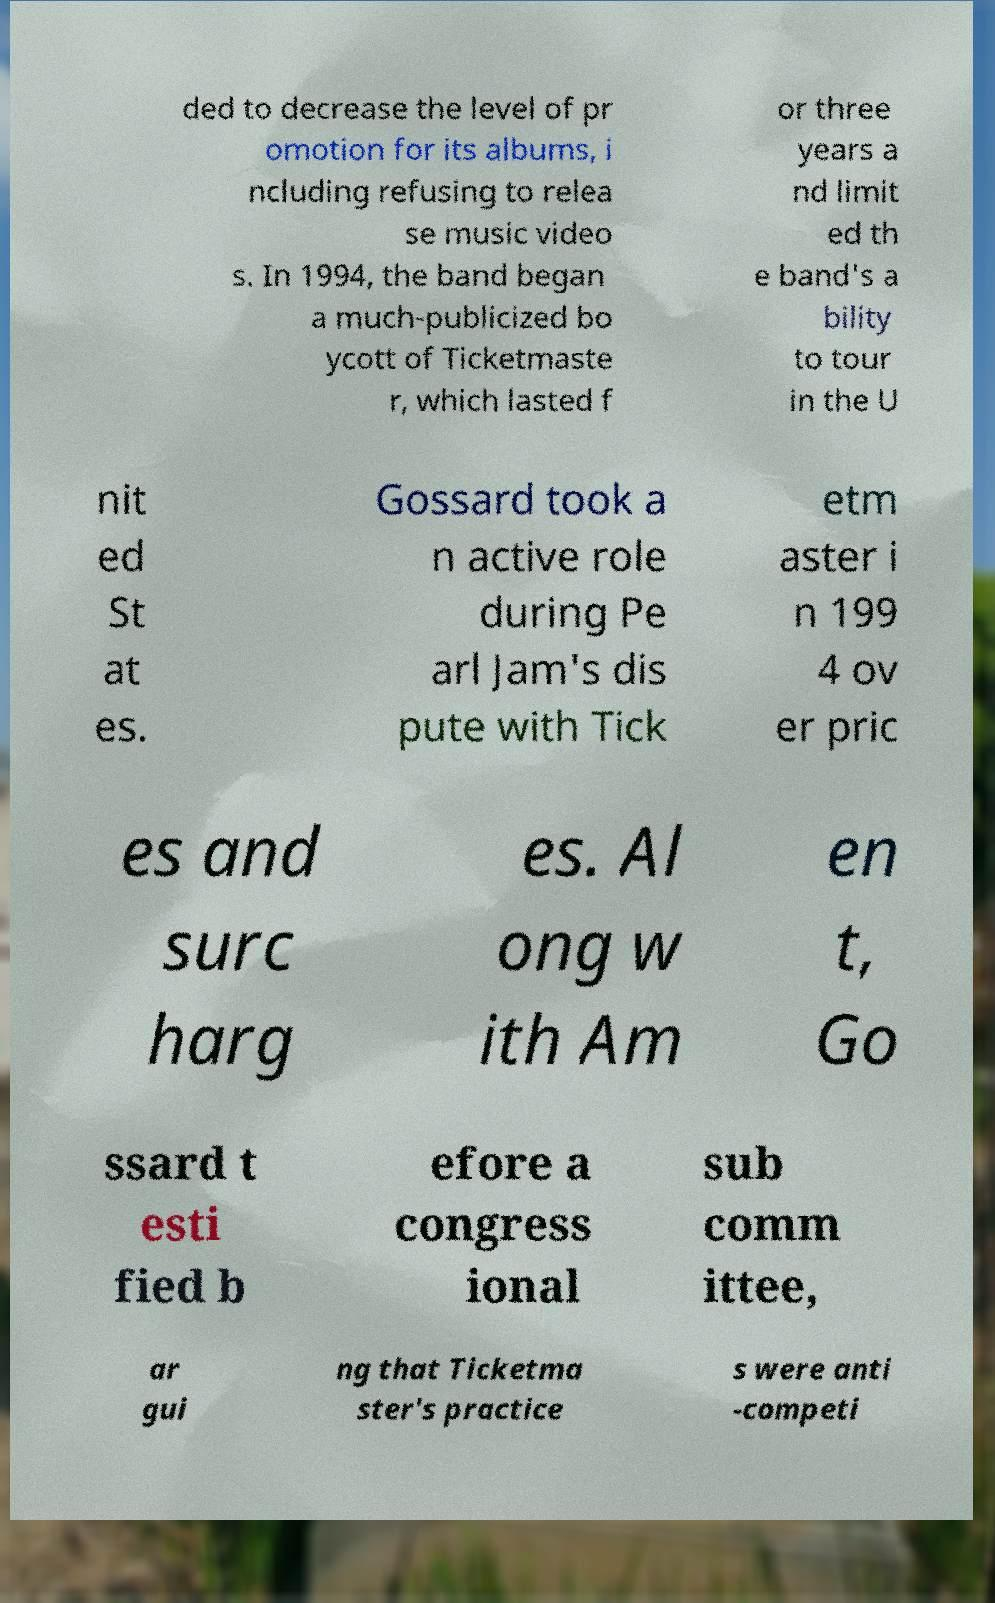I need the written content from this picture converted into text. Can you do that? ded to decrease the level of pr omotion for its albums, i ncluding refusing to relea se music video s. In 1994, the band began a much-publicized bo ycott of Ticketmaste r, which lasted f or three years a nd limit ed th e band's a bility to tour in the U nit ed St at es. Gossard took a n active role during Pe arl Jam's dis pute with Tick etm aster i n 199 4 ov er pric es and surc harg es. Al ong w ith Am en t, Go ssard t esti fied b efore a congress ional sub comm ittee, ar gui ng that Ticketma ster's practice s were anti -competi 